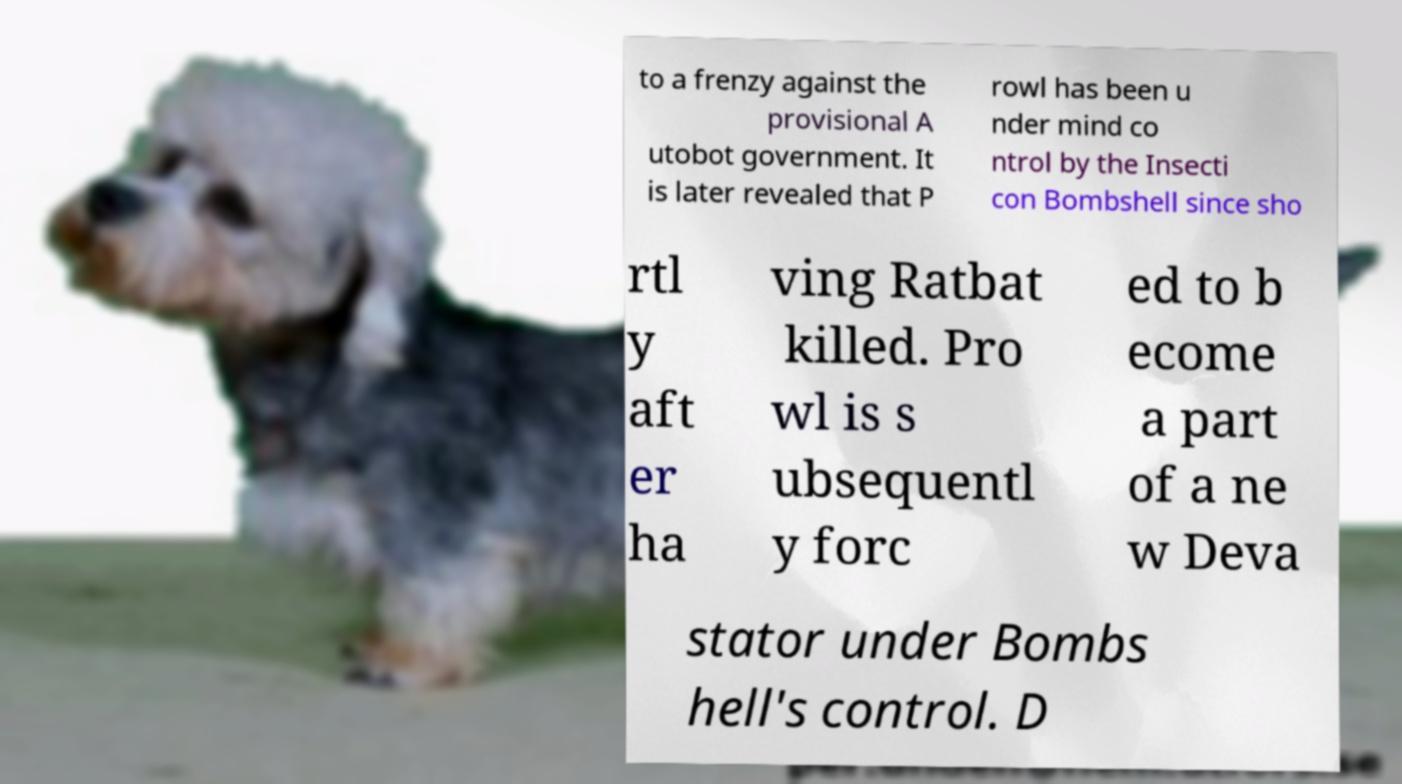What messages or text are displayed in this image? I need them in a readable, typed format. to a frenzy against the provisional A utobot government. It is later revealed that P rowl has been u nder mind co ntrol by the Insecti con Bombshell since sho rtl y aft er ha ving Ratbat killed. Pro wl is s ubsequentl y forc ed to b ecome a part of a ne w Deva stator under Bombs hell's control. D 